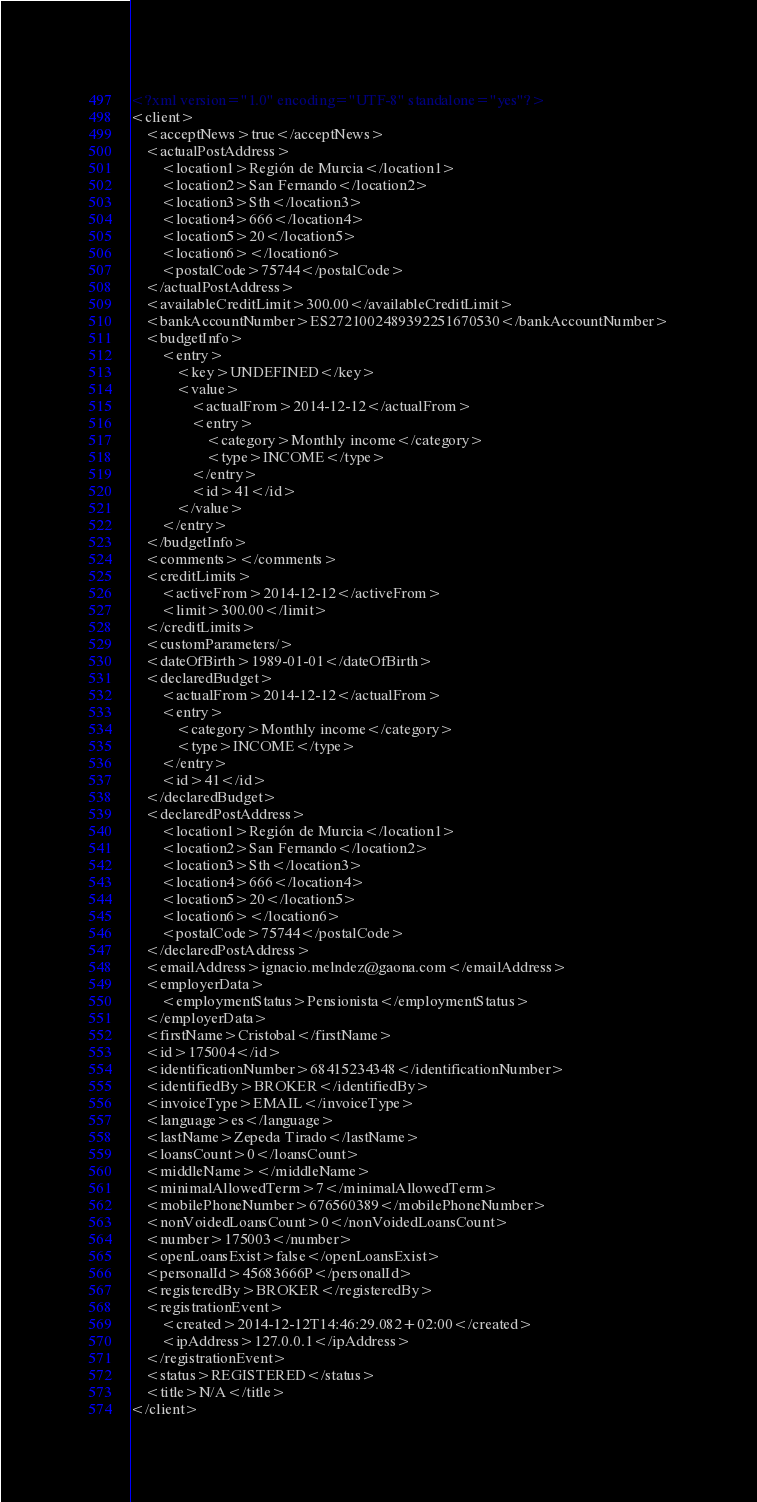Convert code to text. <code><loc_0><loc_0><loc_500><loc_500><_XML_><?xml version="1.0" encoding="UTF-8" standalone="yes"?>
<client>
    <acceptNews>true</acceptNews>
    <actualPostAddress>
        <location1>Región de Murcia</location1>
        <location2>San Fernando</location2>
        <location3>Sth</location3>
        <location4>666</location4>
        <location5>20</location5>
        <location6></location6>
        <postalCode>75744</postalCode>
    </actualPostAddress>
    <availableCreditLimit>300.00</availableCreditLimit>
    <bankAccountNumber>ES2721002489392251670530</bankAccountNumber>
    <budgetInfo>
        <entry>
            <key>UNDEFINED</key>
            <value>
                <actualFrom>2014-12-12</actualFrom>
                <entry>
                    <category>Monthly income</category>
                    <type>INCOME</type>
                </entry>
                <id>41</id>
            </value>
        </entry>
    </budgetInfo>
    <comments></comments>
    <creditLimits>
        <activeFrom>2014-12-12</activeFrom>
        <limit>300.00</limit>
    </creditLimits>
    <customParameters/>
    <dateOfBirth>1989-01-01</dateOfBirth>
    <declaredBudget>
        <actualFrom>2014-12-12</actualFrom>
        <entry>
            <category>Monthly income</category>
            <type>INCOME</type>
        </entry>
        <id>41</id>
    </declaredBudget>
    <declaredPostAddress>
        <location1>Región de Murcia</location1>
        <location2>San Fernando</location2>
        <location3>Sth</location3>
        <location4>666</location4>
        <location5>20</location5>
        <location6></location6>
        <postalCode>75744</postalCode>
    </declaredPostAddress>
    <emailAddress>ignacio.melndez@gaona.com</emailAddress>
    <employerData>
        <employmentStatus>Pensionista</employmentStatus>
    </employerData>
    <firstName>Cristobal</firstName>
    <id>175004</id>
    <identificationNumber>68415234348</identificationNumber>
    <identifiedBy>BROKER</identifiedBy>
    <invoiceType>EMAIL</invoiceType>
    <language>es</language>
    <lastName>Zepeda Tirado</lastName>
    <loansCount>0</loansCount>
    <middleName></middleName>
    <minimalAllowedTerm>7</minimalAllowedTerm>
    <mobilePhoneNumber>676560389</mobilePhoneNumber>
    <nonVoidedLoansCount>0</nonVoidedLoansCount>
    <number>175003</number>
    <openLoansExist>false</openLoansExist>
    <personalId>45683666P</personalId>
    <registeredBy>BROKER</registeredBy>
    <registrationEvent>
        <created>2014-12-12T14:46:29.082+02:00</created>
        <ipAddress>127.0.0.1</ipAddress>
    </registrationEvent>
    <status>REGISTERED</status>
    <title>N/A</title>
</client>
</code> 